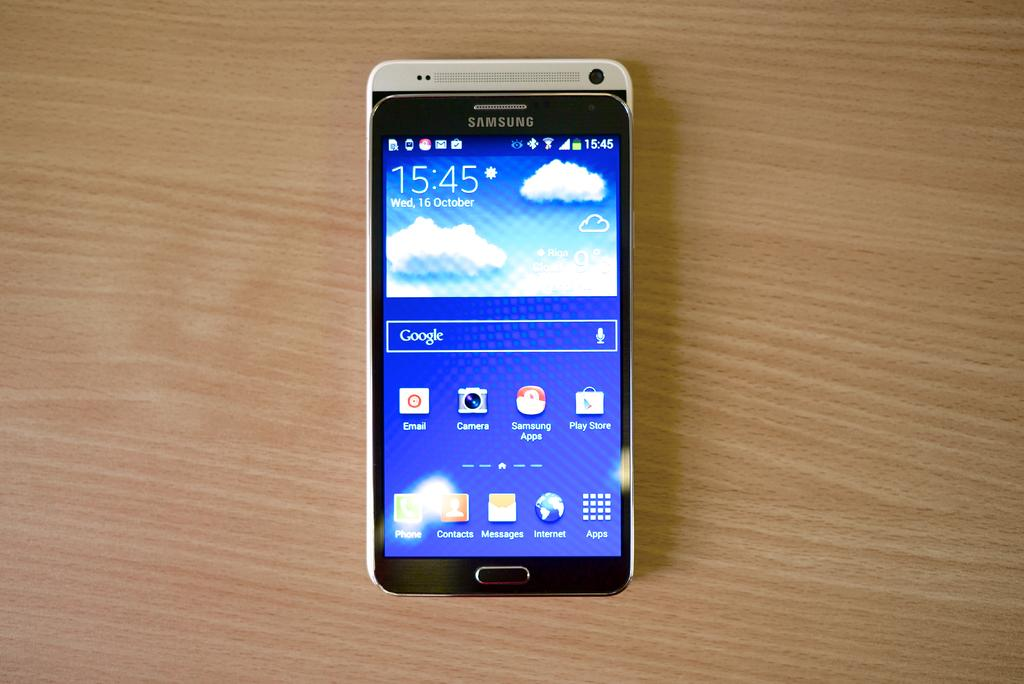<image>
Summarize the visual content of the image. a Samsung cell phone displaying 15:45 as the time 